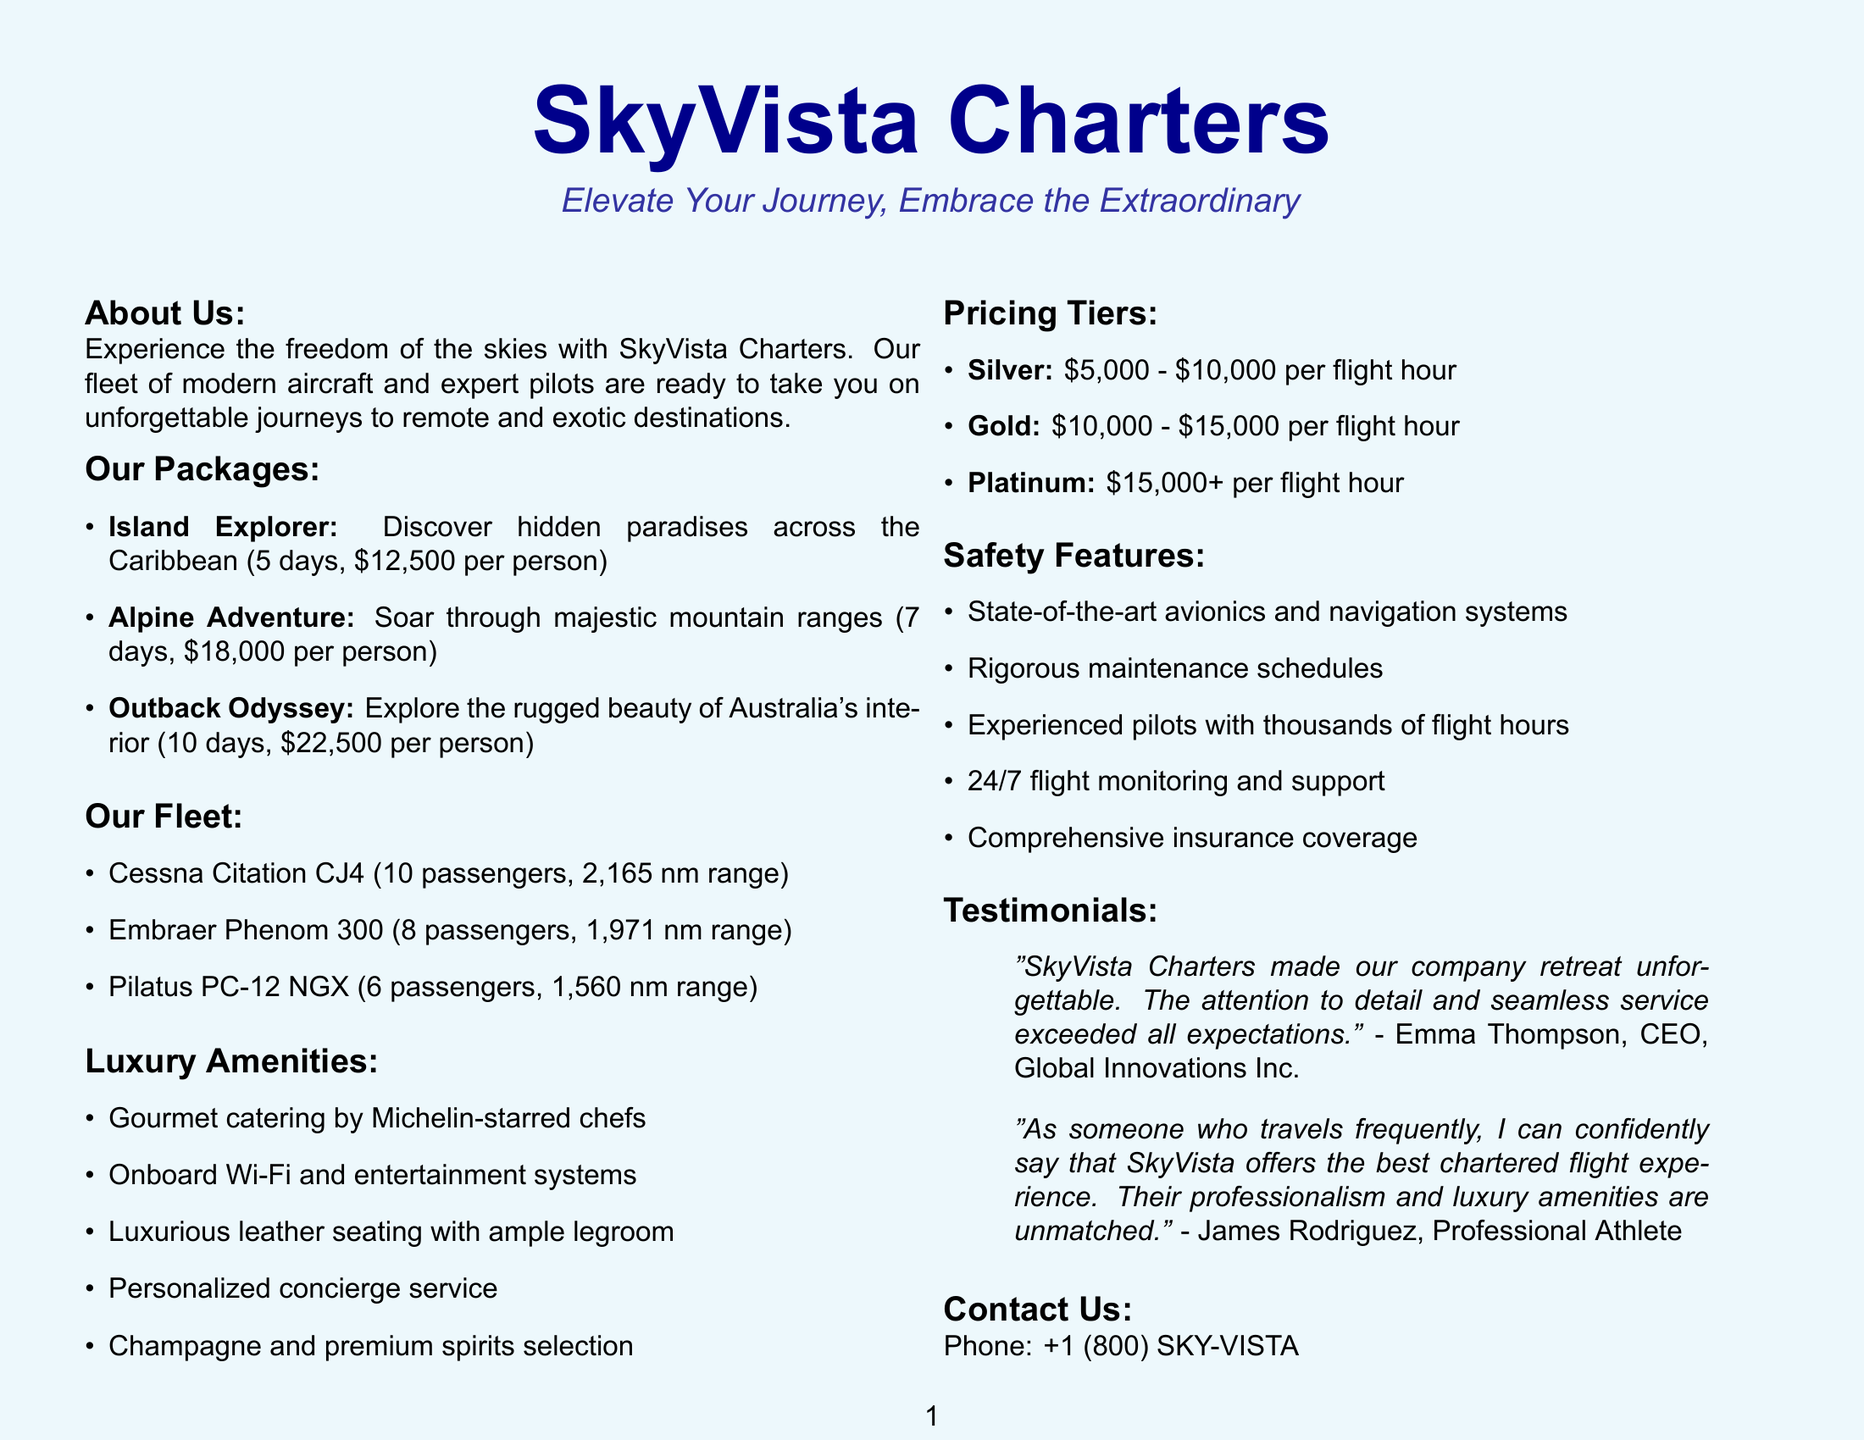What is the company name? The company name is explicitly stated at the beginning of the document.
Answer: SkyVista Charters What is the slogan of SkyVista Charters? The slogan is presented directly under the company name in the introduction section.
Answer: Elevate Your Journey, Embrace the Extraordinary How long is the Island Explorer package? The duration of the package is mentioned alongside its description.
Answer: 5 days What are the destinations for the Alpine Adventure package? The destinations are listed under each package description in the document.
Answer: Courchevel, St. Moritz, Zermatt What model of aircraft has a capacity of 10 passengers? This information is directly included in the aircraft fleet section, which lists model names along with their capacities.
Answer: Cessna Citation CJ4 What features are included in the Platinum pricing tier? The document outlines specific features tied to each pricing tier, focusing on the Platinum tier.
Answer: Ultra-luxury aircraft, Michelin-starred catering, 24/7 concierge service, Exclusive airport lounge access, Bespoke itinerary planning Which luxury amenity is provided by Michelin-starred chefs? This luxury amenity is explicitly mentioned in the list of amenities provided in the brochure.
Answer: Gourmet catering Who is quoted in the testimonial about the unforgettable company retreat? This information is found in the testimonials section, where client names and their quotes are provided.
Answer: Emma Thompson What is the price range for Gold pricing tier? The price range for the Gold tier is directly listed in the pricing tiers section of the document.
Answer: $10,000 - $15,000 per flight hour What is included in the safety features? The list of safety features is provided to ensure clients of the company's professionalism and safety.
Answer: State-of-the-art avionics and navigation systems, Rigorous maintenance schedules, Experienced pilots with thousands of flight hours, 24/7 flight monitoring and support, Comprehensive insurance coverage 